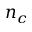Convert formula to latex. <formula><loc_0><loc_0><loc_500><loc_500>n _ { c }</formula> 